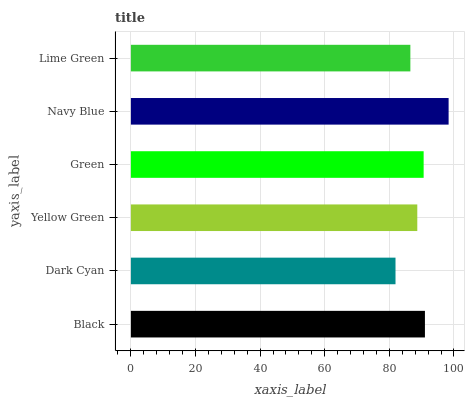Is Dark Cyan the minimum?
Answer yes or no. Yes. Is Navy Blue the maximum?
Answer yes or no. Yes. Is Yellow Green the minimum?
Answer yes or no. No. Is Yellow Green the maximum?
Answer yes or no. No. Is Yellow Green greater than Dark Cyan?
Answer yes or no. Yes. Is Dark Cyan less than Yellow Green?
Answer yes or no. Yes. Is Dark Cyan greater than Yellow Green?
Answer yes or no. No. Is Yellow Green less than Dark Cyan?
Answer yes or no. No. Is Green the high median?
Answer yes or no. Yes. Is Yellow Green the low median?
Answer yes or no. Yes. Is Navy Blue the high median?
Answer yes or no. No. Is Dark Cyan the low median?
Answer yes or no. No. 